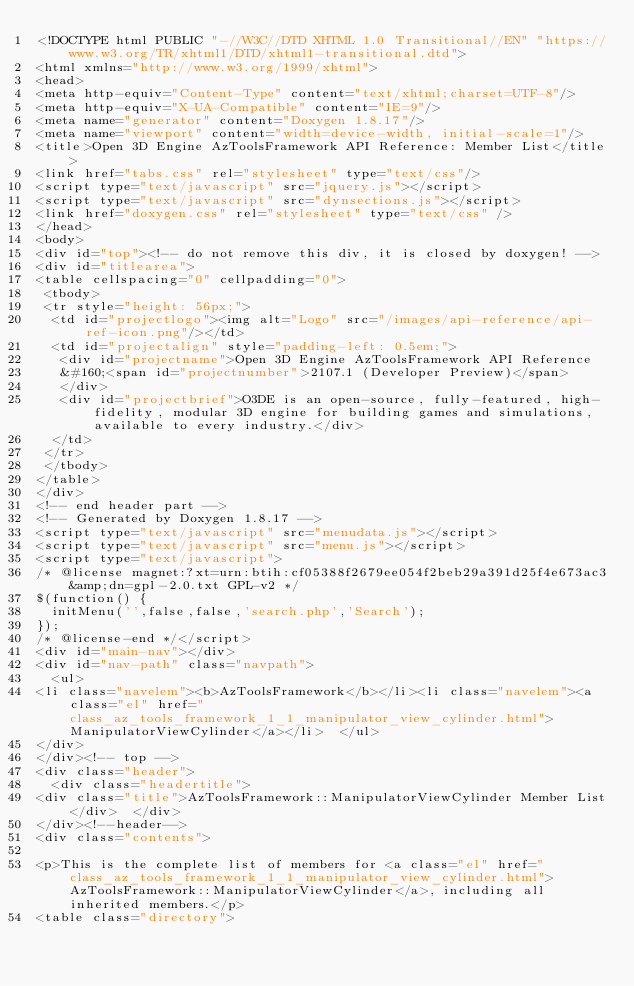Convert code to text. <code><loc_0><loc_0><loc_500><loc_500><_HTML_><!DOCTYPE html PUBLIC "-//W3C//DTD XHTML 1.0 Transitional//EN" "https://www.w3.org/TR/xhtml1/DTD/xhtml1-transitional.dtd">
<html xmlns="http://www.w3.org/1999/xhtml">
<head>
<meta http-equiv="Content-Type" content="text/xhtml;charset=UTF-8"/>
<meta http-equiv="X-UA-Compatible" content="IE=9"/>
<meta name="generator" content="Doxygen 1.8.17"/>
<meta name="viewport" content="width=device-width, initial-scale=1"/>
<title>Open 3D Engine AzToolsFramework API Reference: Member List</title>
<link href="tabs.css" rel="stylesheet" type="text/css"/>
<script type="text/javascript" src="jquery.js"></script>
<script type="text/javascript" src="dynsections.js"></script>
<link href="doxygen.css" rel="stylesheet" type="text/css" />
</head>
<body>
<div id="top"><!-- do not remove this div, it is closed by doxygen! -->
<div id="titlearea">
<table cellspacing="0" cellpadding="0">
 <tbody>
 <tr style="height: 56px;">
  <td id="projectlogo"><img alt="Logo" src="/images/api-reference/api-ref-icon.png"/></td>
  <td id="projectalign" style="padding-left: 0.5em;">
   <div id="projectname">Open 3D Engine AzToolsFramework API Reference
   &#160;<span id="projectnumber">2107.1 (Developer Preview)</span>
   </div>
   <div id="projectbrief">O3DE is an open-source, fully-featured, high-fidelity, modular 3D engine for building games and simulations, available to every industry.</div>
  </td>
 </tr>
 </tbody>
</table>
</div>
<!-- end header part -->
<!-- Generated by Doxygen 1.8.17 -->
<script type="text/javascript" src="menudata.js"></script>
<script type="text/javascript" src="menu.js"></script>
<script type="text/javascript">
/* @license magnet:?xt=urn:btih:cf05388f2679ee054f2beb29a391d25f4e673ac3&amp;dn=gpl-2.0.txt GPL-v2 */
$(function() {
  initMenu('',false,false,'search.php','Search');
});
/* @license-end */</script>
<div id="main-nav"></div>
<div id="nav-path" class="navpath">
  <ul>
<li class="navelem"><b>AzToolsFramework</b></li><li class="navelem"><a class="el" href="class_az_tools_framework_1_1_manipulator_view_cylinder.html">ManipulatorViewCylinder</a></li>  </ul>
</div>
</div><!-- top -->
<div class="header">
  <div class="headertitle">
<div class="title">AzToolsFramework::ManipulatorViewCylinder Member List</div>  </div>
</div><!--header-->
<div class="contents">

<p>This is the complete list of members for <a class="el" href="class_az_tools_framework_1_1_manipulator_view_cylinder.html">AzToolsFramework::ManipulatorViewCylinder</a>, including all inherited members.</p>
<table class="directory"></code> 